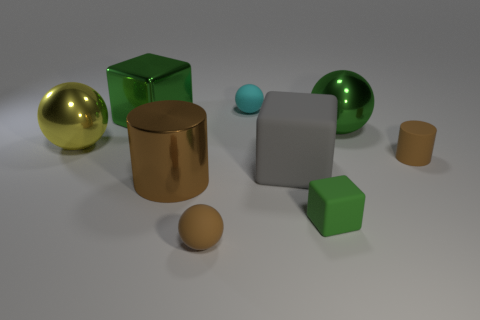How many objects are either tiny cylinders or large metal cylinders?
Ensure brevity in your answer.  2. How many tiny things are either cyan spheres or cylinders?
Offer a very short reply. 2. Is there anything else that is the same color as the large shiny cylinder?
Make the answer very short. Yes. There is a brown thing that is both on the right side of the large brown metallic object and to the left of the green sphere; what is its size?
Make the answer very short. Small. Is the color of the small block that is in front of the yellow shiny object the same as the shiny sphere that is right of the tiny cyan rubber thing?
Make the answer very short. Yes. How many other things are the same material as the large yellow sphere?
Offer a very short reply. 3. What shape is the thing that is both in front of the large green ball and to the right of the tiny matte block?
Keep it short and to the point. Cylinder. Is the color of the big cylinder the same as the small thing that is behind the green metallic ball?
Provide a succinct answer. No. There is a cylinder that is on the right side of the cyan matte thing; does it have the same size as the gray thing?
Provide a succinct answer. No. What material is the small brown thing that is the same shape as the big yellow object?
Provide a succinct answer. Rubber. 